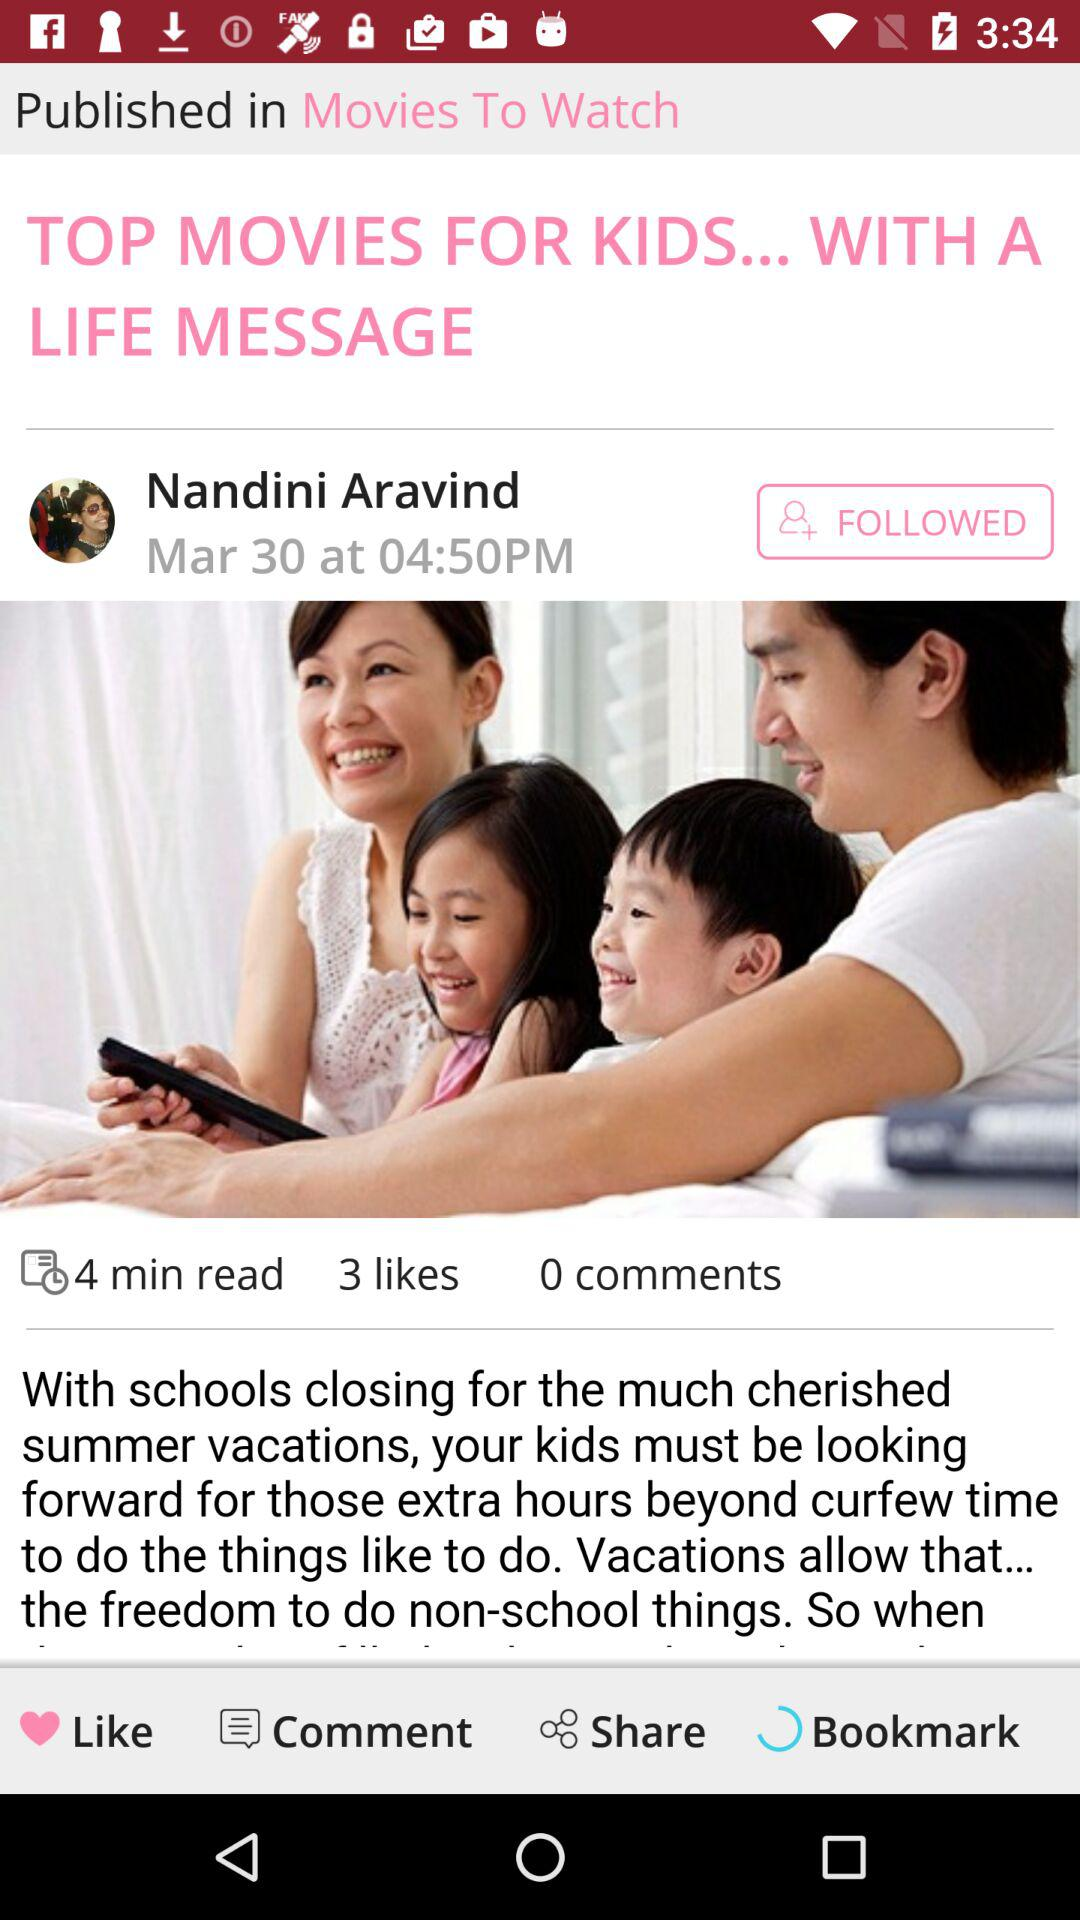How many more likes does the post have than comments?
Answer the question using a single word or phrase. 3 